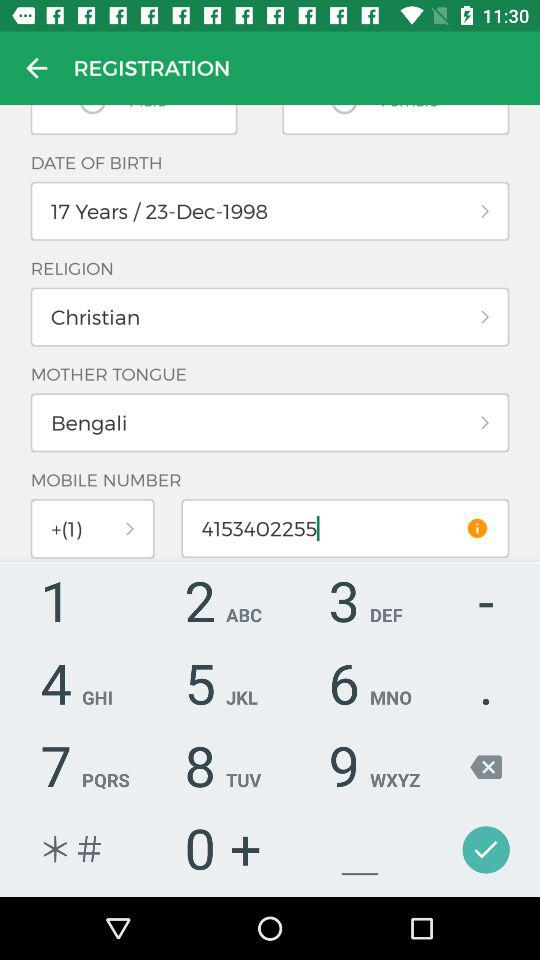What application is used for log in? The application is "Facebook". 